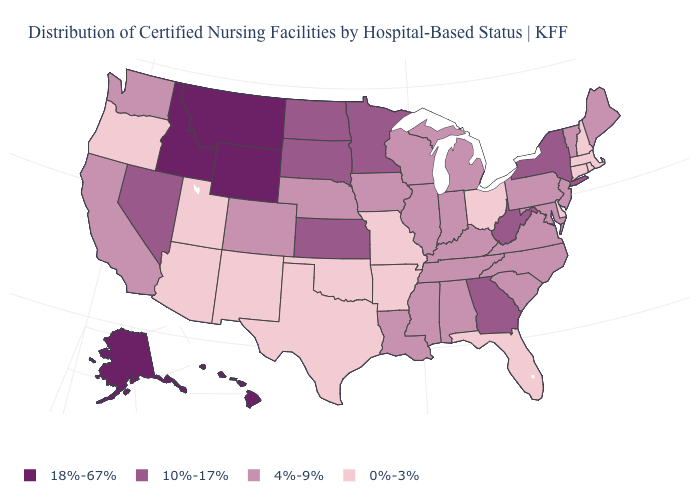Among the states that border Illinois , does Missouri have the lowest value?
Concise answer only. Yes. What is the value of Hawaii?
Quick response, please. 18%-67%. Name the states that have a value in the range 0%-3%?
Give a very brief answer. Arizona, Arkansas, Connecticut, Delaware, Florida, Massachusetts, Missouri, New Hampshire, New Mexico, Ohio, Oklahoma, Oregon, Rhode Island, Texas, Utah. What is the value of New York?
Be succinct. 10%-17%. Which states have the highest value in the USA?
Write a very short answer. Alaska, Hawaii, Idaho, Montana, Wyoming. Name the states that have a value in the range 18%-67%?
Answer briefly. Alaska, Hawaii, Idaho, Montana, Wyoming. Does Maryland have the same value as Georgia?
Concise answer only. No. What is the value of Nebraska?
Write a very short answer. 4%-9%. What is the highest value in states that border Kentucky?
Short answer required. 10%-17%. What is the value of Texas?
Write a very short answer. 0%-3%. What is the value of Montana?
Quick response, please. 18%-67%. Name the states that have a value in the range 10%-17%?
Answer briefly. Georgia, Kansas, Minnesota, Nevada, New York, North Dakota, South Dakota, West Virginia. What is the value of Illinois?
Write a very short answer. 4%-9%. 